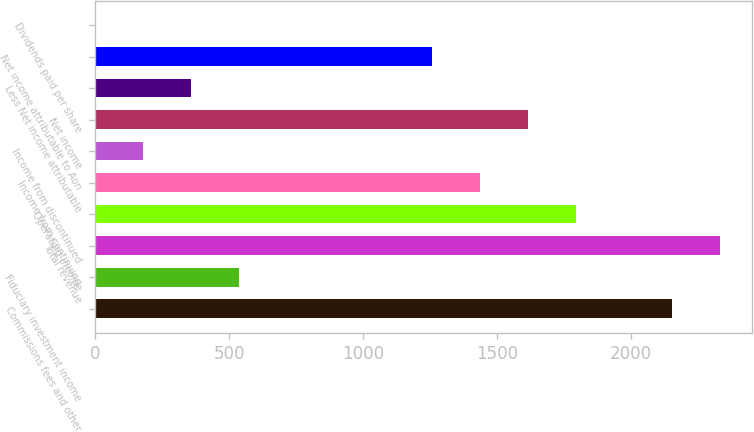Convert chart. <chart><loc_0><loc_0><loc_500><loc_500><bar_chart><fcel>Commissions fees and other<fcel>Fiduciary investment income<fcel>Total revenue<fcel>Operating income<fcel>Income from continuing<fcel>Income from discontinued<fcel>Net income<fcel>Less Net income attributable<fcel>Net income attributable to Aon<fcel>Dividends paid per share<nl><fcel>2152.76<fcel>538.3<fcel>2332.15<fcel>1793.98<fcel>1435.21<fcel>179.53<fcel>1614.6<fcel>358.91<fcel>1255.83<fcel>0.15<nl></chart> 